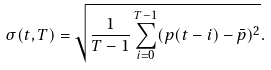<formula> <loc_0><loc_0><loc_500><loc_500>\sigma ( t , T ) = \sqrt { \frac { 1 } { T - 1 } \sum _ { i = 0 } ^ { T - 1 } ( p ( t - i ) - \bar { p } ) ^ { 2 } } .</formula> 